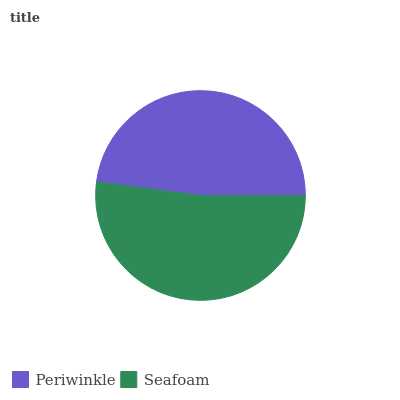Is Periwinkle the minimum?
Answer yes or no. Yes. Is Seafoam the maximum?
Answer yes or no. Yes. Is Seafoam the minimum?
Answer yes or no. No. Is Seafoam greater than Periwinkle?
Answer yes or no. Yes. Is Periwinkle less than Seafoam?
Answer yes or no. Yes. Is Periwinkle greater than Seafoam?
Answer yes or no. No. Is Seafoam less than Periwinkle?
Answer yes or no. No. Is Seafoam the high median?
Answer yes or no. Yes. Is Periwinkle the low median?
Answer yes or no. Yes. Is Periwinkle the high median?
Answer yes or no. No. Is Seafoam the low median?
Answer yes or no. No. 